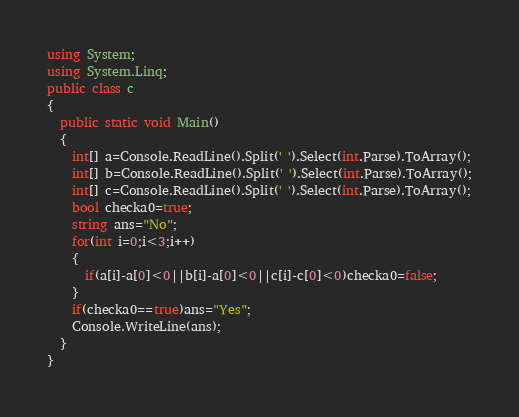Convert code to text. <code><loc_0><loc_0><loc_500><loc_500><_C#_>using System;
using System.Linq;
public class c
{
  public static void Main()
  {
    int[] a=Console.ReadLine().Split(' ').Select(int.Parse).ToArray();
    int[] b=Console.ReadLine().Split(' ').Select(int.Parse).ToArray();
    int[] c=Console.ReadLine().Split(' ').Select(int.Parse).ToArray();
    bool checka0=true;
    string ans="No";
    for(int i=0;i<3;i++)
    {
      if(a[i]-a[0]<0||b[i]-a[0]<0||c[i]-c[0]<0)checka0=false;
    }
    if(checka0==true)ans="Yes";
    Console.WriteLine(ans);
  }
}
</code> 